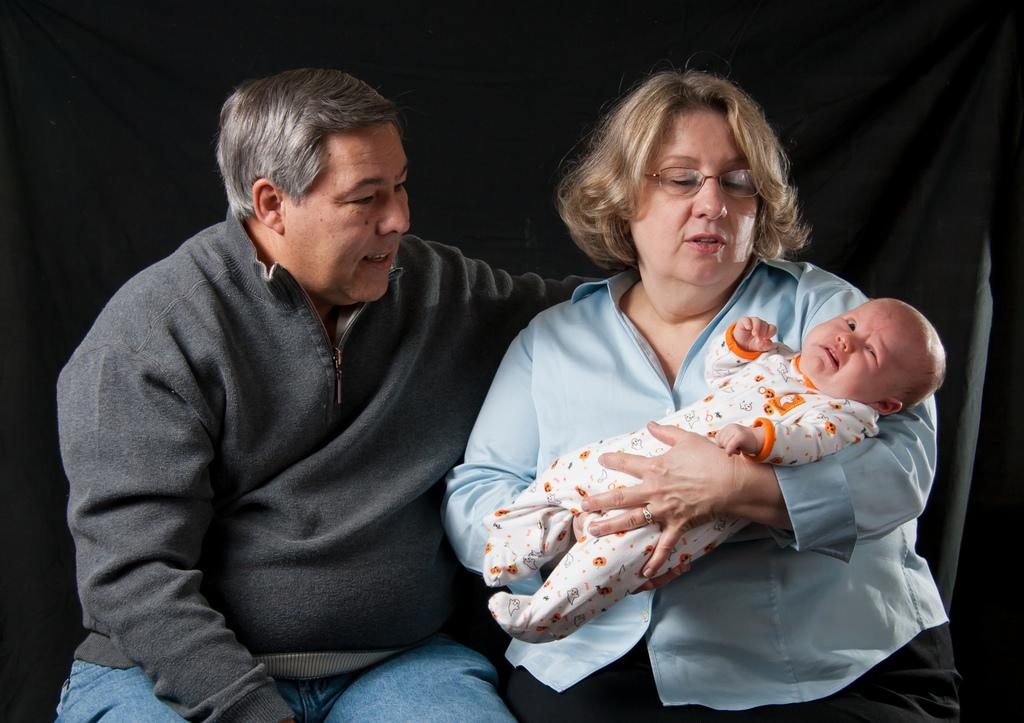Who are the people in the image? There is a man and a woman in the image. What is the baby doing in the image? A baby is sitting on a bench in the image. Where is the bench located in the image? The bench is in the center of the image. What can be seen in the background of the image? There is cloth visible in the background of the image. What is the caption for the page the image is on? There is no caption or page mentioned in the provided facts, as the focus is on the image itself. 